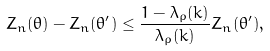Convert formula to latex. <formula><loc_0><loc_0><loc_500><loc_500>Z _ { n } ( \theta ) - Z _ { n } ( \theta ^ { \prime } ) \leq \frac { 1 - \lambda _ { \rho } ( k ) } { \lambda _ { \rho } ( k ) } Z _ { n } ( \theta ^ { \prime } ) ,</formula> 